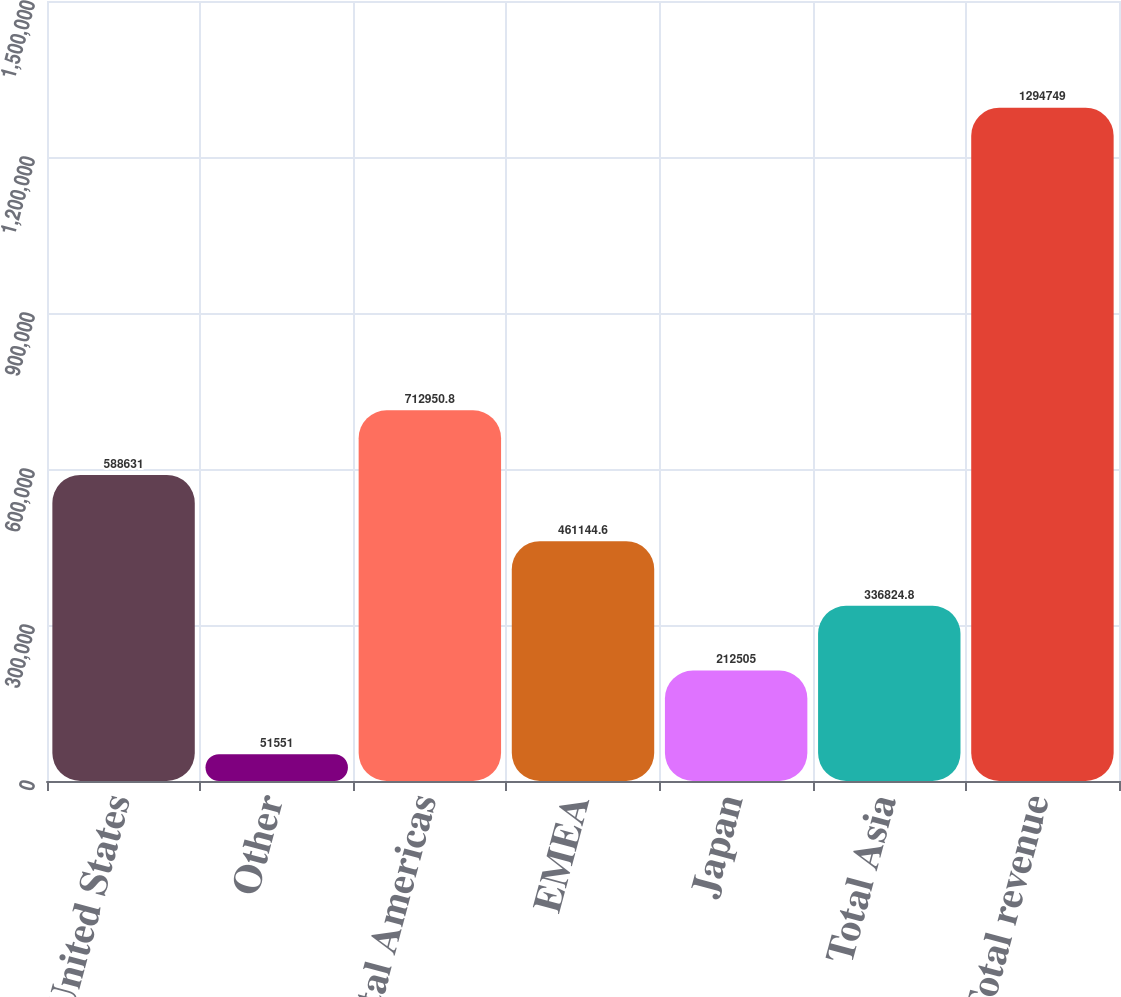Convert chart to OTSL. <chart><loc_0><loc_0><loc_500><loc_500><bar_chart><fcel>United States<fcel>Other<fcel>Total Americas<fcel>EMEA<fcel>Japan<fcel>Total Asia<fcel>Total revenue<nl><fcel>588631<fcel>51551<fcel>712951<fcel>461145<fcel>212505<fcel>336825<fcel>1.29475e+06<nl></chart> 